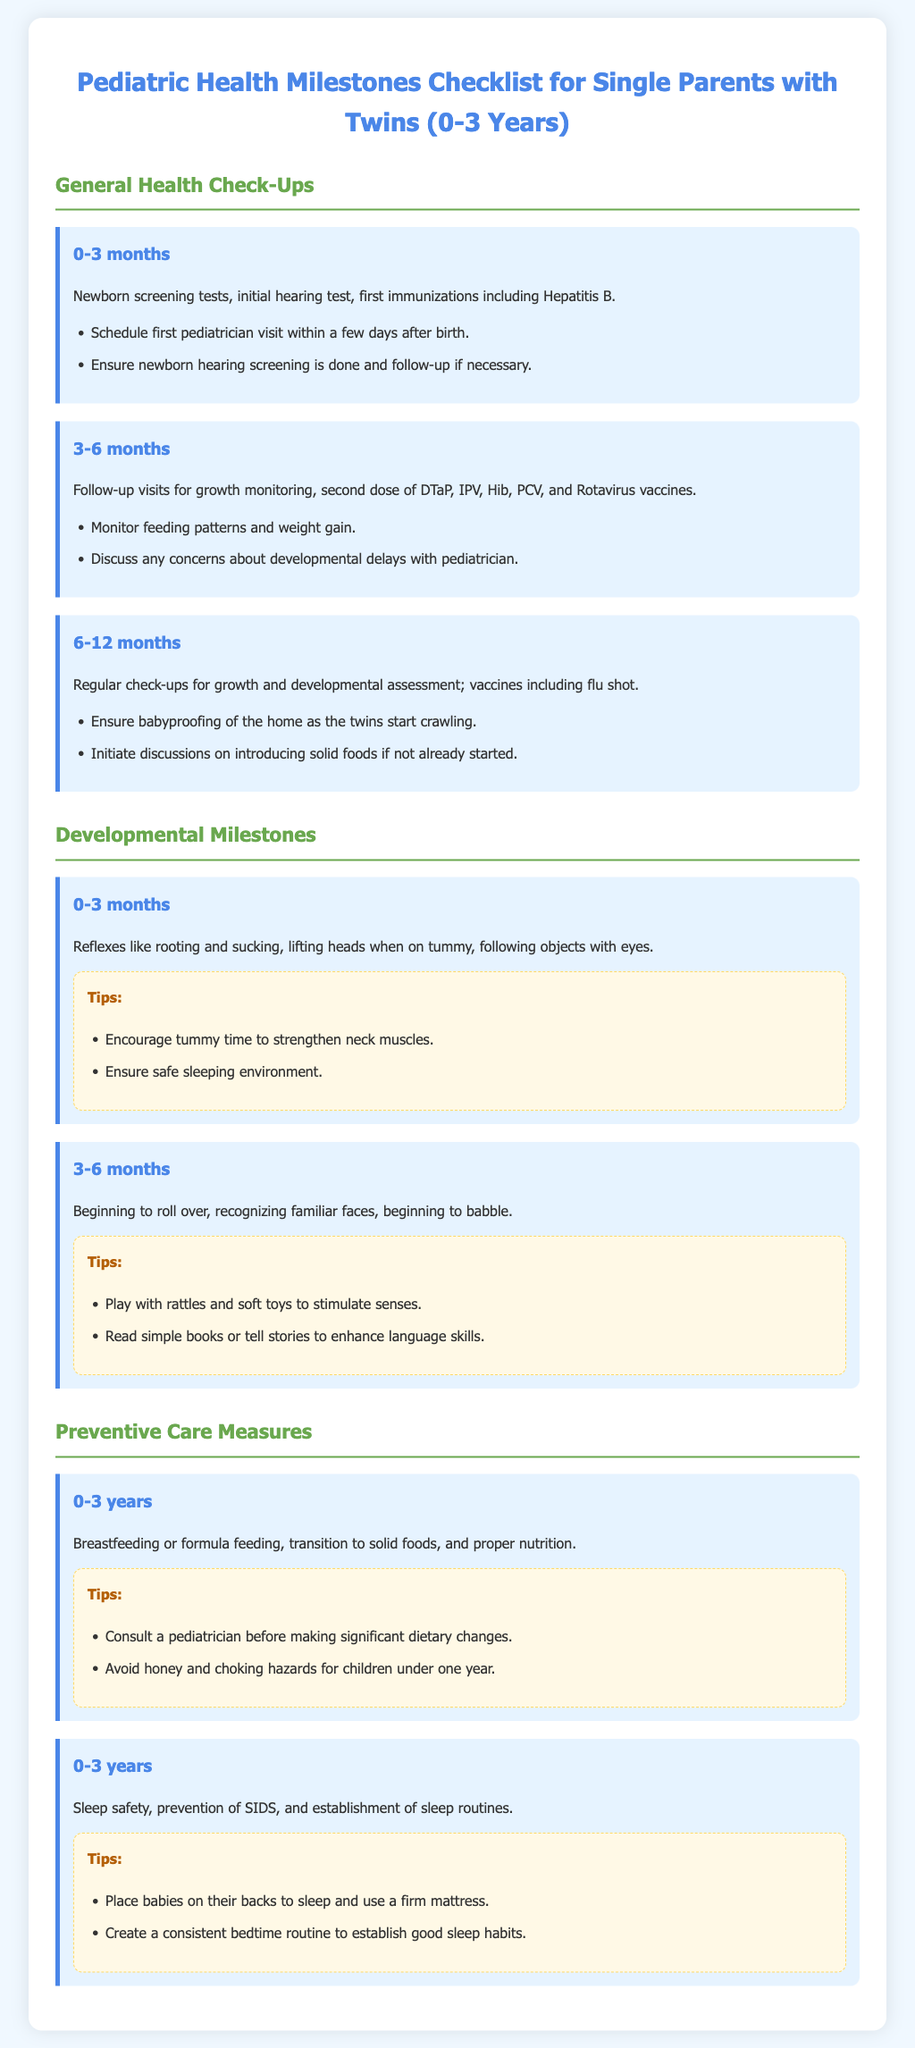What is the first immunization for newborns? The first immunization for newborns is Hepatitis B as mentioned in the 0-3 months milestone section.
Answer: Hepatitis B What age group does this checklist cover? The checklist covers the age group from 0 to 3 years, as stated in the document title.
Answer: 0-3 years Which vaccines are given at 3-6 months? The vaccines given at 3-6 months include DTaP, IPV, Hib, PCV, and Rotavirus, as outlined in the 3-6 months milestone section.
Answer: DTaP, IPV, Hib, PCV, and Rotavirus What is a recommended tip for 0-3 months? A recommended tip for 0-3 months is to encourage tummy time to strengthen neck muscles, noted in the tips section for that milestone.
Answer: Encourage tummy time Which developmental milestone is noted for 3-6 months? The developmental milestone for 3-6 months includes beginning to roll over, as stated in the 3-6 months milestone section.
Answer: Beginning to roll over What safety measure is highlighted for sleep? The document highlights placing babies on their backs to sleep as a safety measure to prevent SIDS.
Answer: Place babies on their backs At what age should honey be avoided? The document advises avoiding honey for children under one year, clarified in the preventive care measures section.
Answer: Under one year What is the color scheme for the tips section? The color scheme for the tips section features a background of light yellow with a dashed border, as noted in the document.
Answer: Light yellow with dashed border 